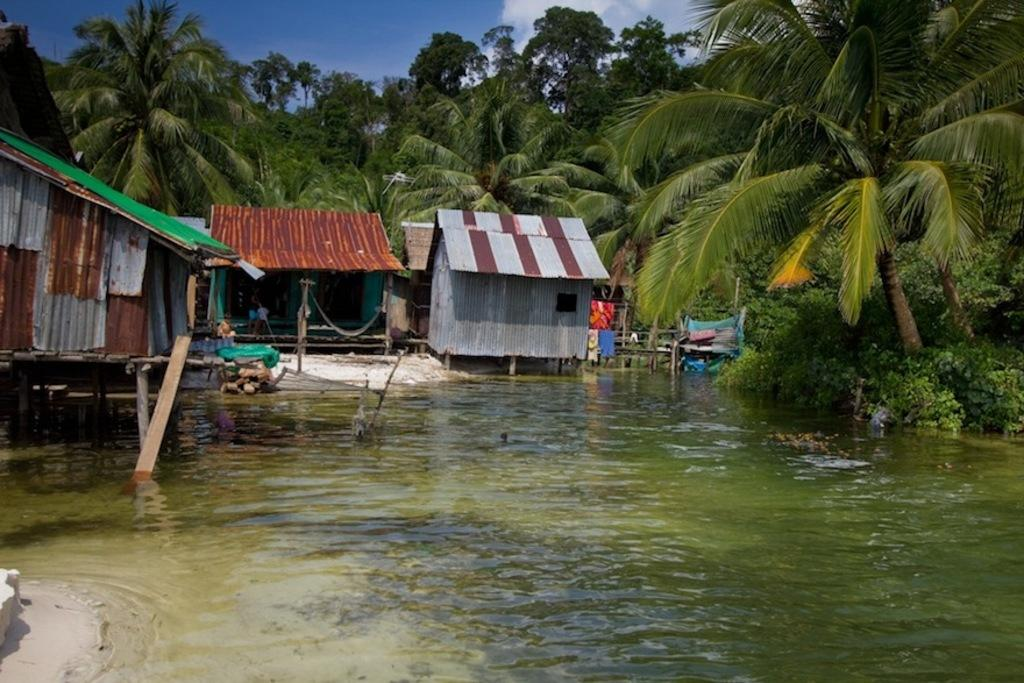What type of structures can be seen in the image? There are houses in the image. What natural element is visible in the image? Water is visible in the image. What man-made objects are present in the image? Pipes are present in the image. What type of vegetation can be seen in the image? Plants and trees are in the image. What else can be seen in the image besides the structures and vegetation? There are objects in the image. What is visible in the background of the image? The sky is visible in the background of the image. Can you identify any living beings in the image? It appears that a person is standing in the image. What type of bun is being used to support the theory in the image? There is no bun or theory present in the image; it features houses, water, pipes, plants, trees, objects, the sky, and a person. How does the bit affect the person standing in the image? There is no bit present in the image, so it cannot affect the person standing in the image. 